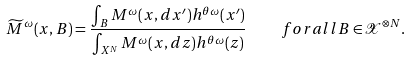Convert formula to latex. <formula><loc_0><loc_0><loc_500><loc_500>\widetilde { M } ^ { \omega } ( x , B ) = \frac { \int _ { B } M ^ { \omega } ( x , d x ^ { \prime } ) h ^ { \theta \omega } ( x ^ { \prime } ) } { \int _ { X ^ { N } } M ^ { \omega } ( x , d z ) h ^ { \theta \omega } ( z ) } \quad f o r a l l B \in \mathcal { X } ^ { \otimes N } .</formula> 